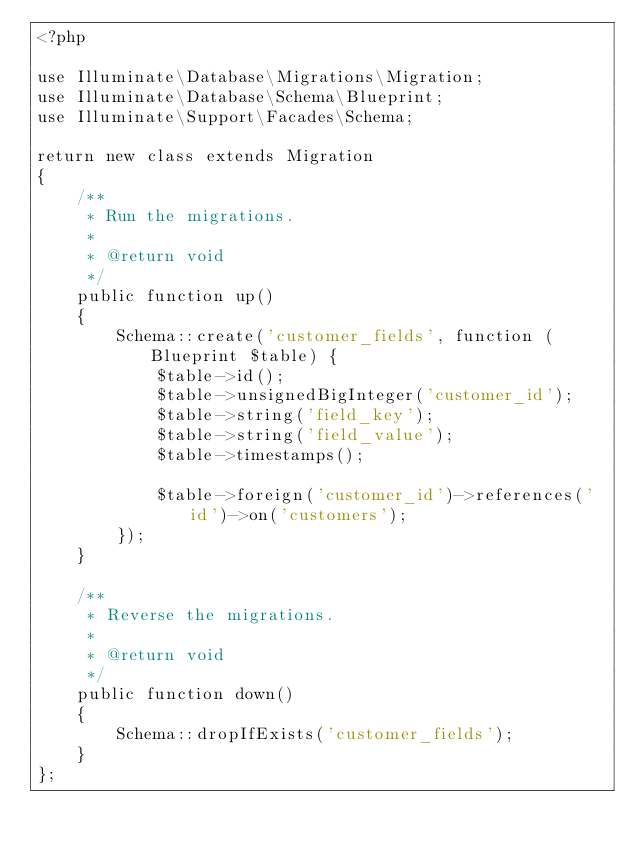Convert code to text. <code><loc_0><loc_0><loc_500><loc_500><_PHP_><?php

use Illuminate\Database\Migrations\Migration;
use Illuminate\Database\Schema\Blueprint;
use Illuminate\Support\Facades\Schema;

return new class extends Migration
{
    /**
     * Run the migrations.
     *
     * @return void
     */
    public function up()
    {
        Schema::create('customer_fields', function (Blueprint $table) {
            $table->id();
            $table->unsignedBigInteger('customer_id');
            $table->string('field_key');
            $table->string('field_value');
            $table->timestamps();

            $table->foreign('customer_id')->references('id')->on('customers');
        });
    }

    /**
     * Reverse the migrations.
     *
     * @return void
     */
    public function down()
    {
        Schema::dropIfExists('customer_fields');
    }
};
</code> 